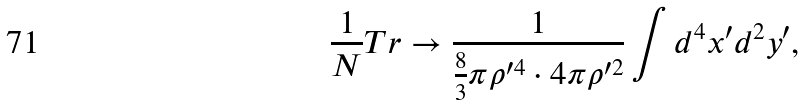<formula> <loc_0><loc_0><loc_500><loc_500>\frac { 1 } { N } T r \rightarrow \frac { 1 } { \frac { 8 } { 3 } \pi \rho ^ { \prime 4 } \cdot 4 \pi \rho ^ { \prime 2 } } \int d ^ { 4 } x ^ { \prime } d ^ { 2 } y ^ { \prime } ,</formula> 